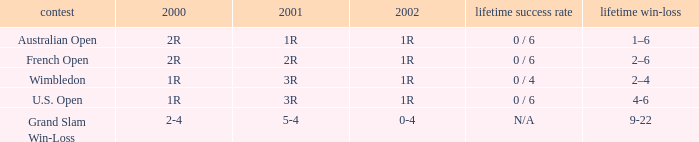In what year 2000 tournment did Angeles Montolio have a career win-loss record of 2-4? Grand Slam Win-Loss. 